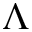<formula> <loc_0><loc_0><loc_500><loc_500>\Lambda</formula> 